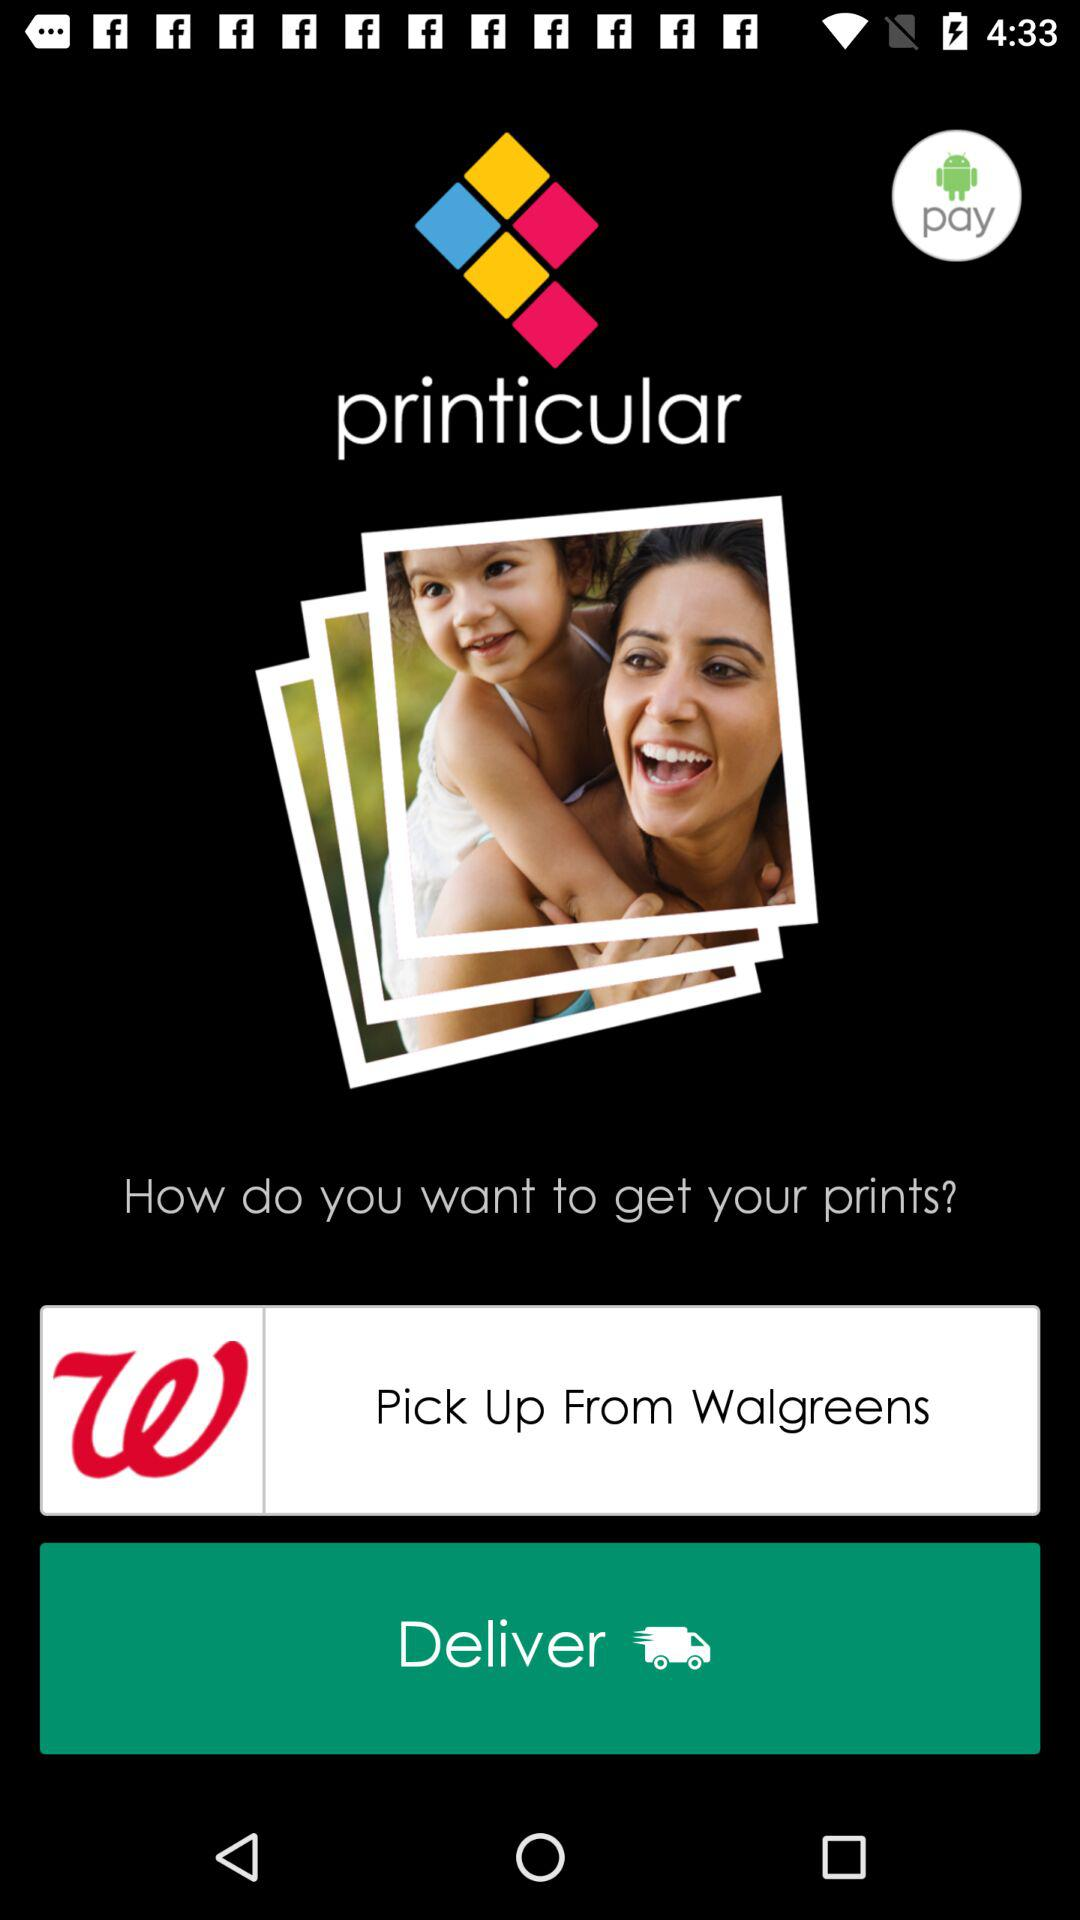What is the application name? The application names are "printicular" and "Walgreens". 